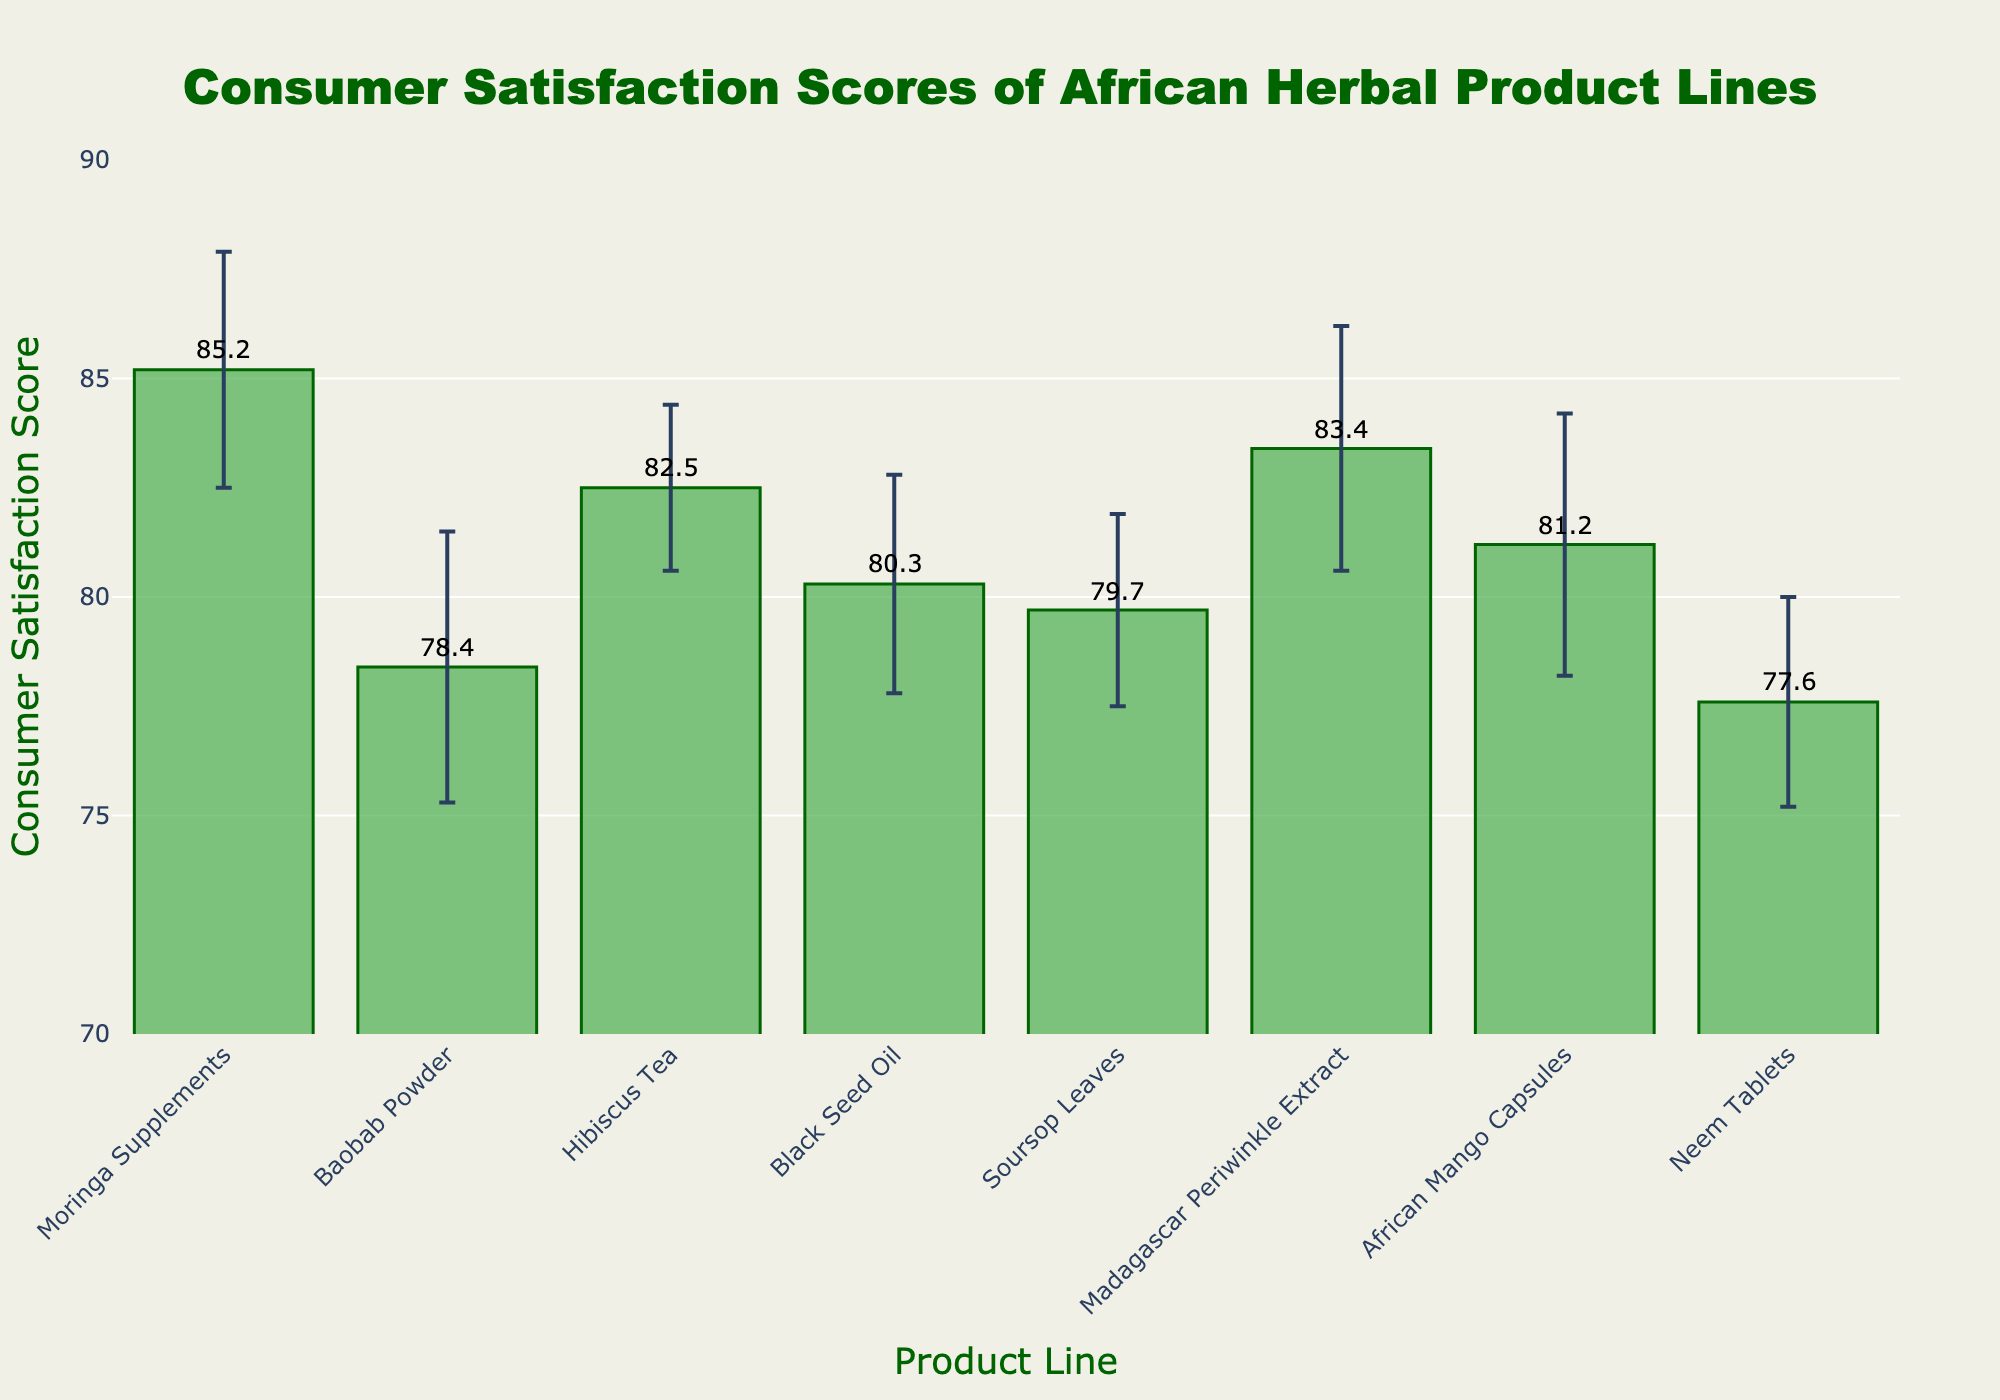What is the title of the bar chart? The title of a chart is usually found at the top and is meant to give a brief description of what the chart is about. In this case, it is displayed prominently at the top center of the figure.
Answer: Consumer Satisfaction Scores of African Herbal Product Lines Which product line has the highest consumer satisfaction score? By examining the heights of the bars or the numerical annotations above them, the tallest bar corresponds to the product line with the highest score.
Answer: Moringa Supplements What's the consumer satisfaction score for Hibiscus Tea? By locating Hibiscus Tea on the x-axis and looking at the bar's height or annotation above it, the satisfaction score can be determined.
Answer: 82.5 Which product line has the smallest error margin? Error bars indicate the margin of error and the smallest one will be the shortest vertical line above the bar representing the product line.
Answer: Hibiscus Tea How much difference is there between the satisfaction scores of African Mango Capsules and Neem Tablets? Subtract the satisfaction score of Neem Tablets from that of African Mango Capsules.
Answer: 81.2 - 77.6 = 3.6 What is the average of the consumer satisfaction scores for all the product lines? Add all the satisfaction scores and divide by the number of product lines: (85.2 + 78.4 + 82.5 + 80.3 + 79.7 + 83.4 + 81.2 + 77.6) / 8
Answer: 81.0 Which product line has the largest range between its satisfaction score and its error margin? Calculate the range (Score + Error Margin) for each product line and compare to find the largest value, e.g., Moringa (85.2 + 2.7 = 87.9) vs. others.
Answer: Moringa Supplements What is the consumer satisfaction score for the product line with the third-highest score? By ranking the scores in descending order, identify the third-highest: (1) Moringa Supplements (2) Madagascar Periwinkle Extract (3) Hibiscus Tea.
Answer: 82.5 How many product lines have scores above 80? Count the number of bars or annotations that indicate a score above 80.
Answer: 5 What is the difference in consumer satisfaction scores between the highest-ranked and lowest-ranked product lines? Subtract the lowest score (Neem Tablets) from the highest score (Moringa Supplements): 85.2 - 77.6.
Answer: 7.6 Which product line has a satisfaction score closest to the midpoint of the chart's y-axis range? The midpoint of a range from 70 to 90 is (70+90)/2 = 80. Identify the score closest to 80.
Answer: Black Seed Oil 